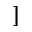<formula> <loc_0><loc_0><loc_500><loc_500>]</formula> 